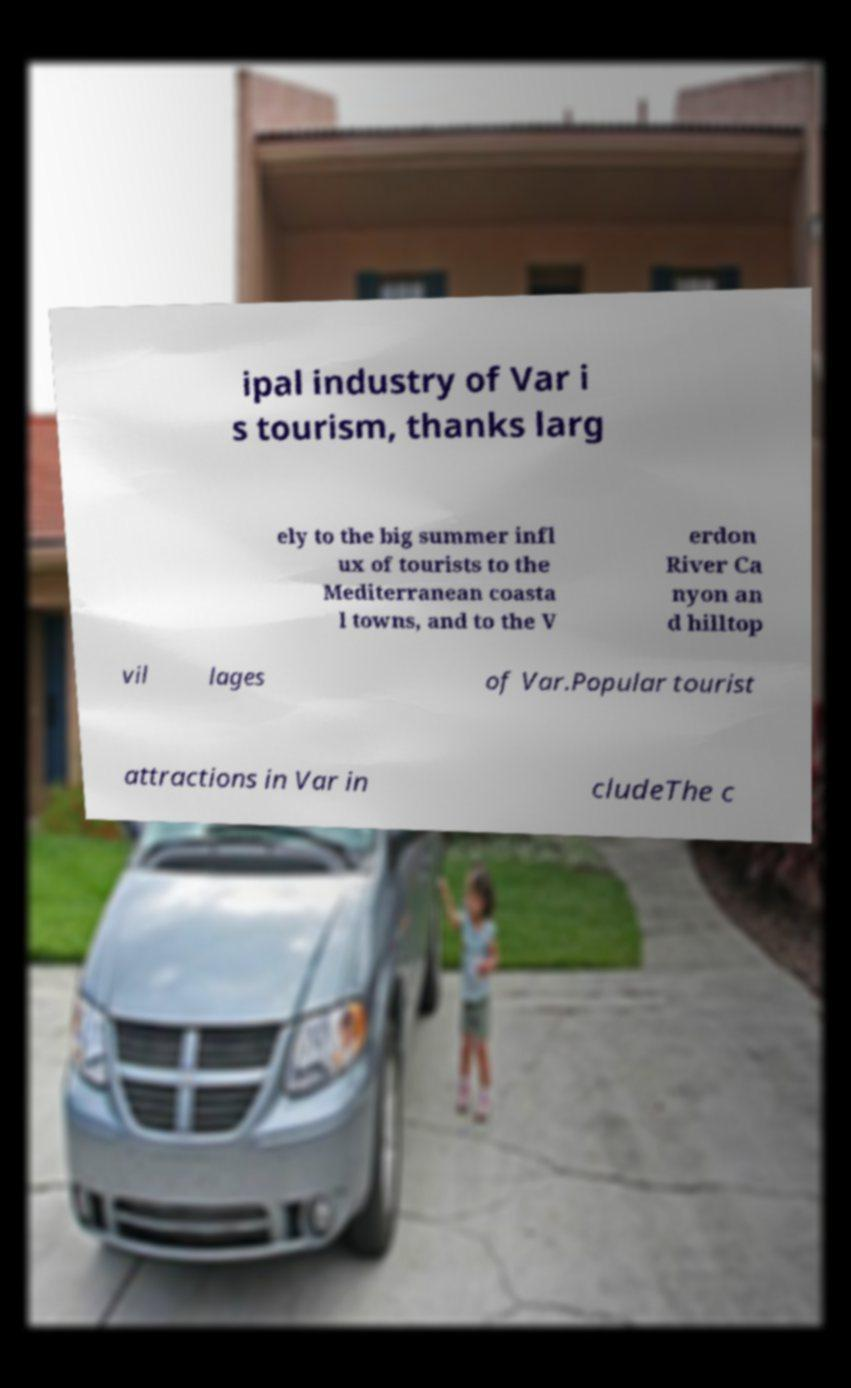What messages or text are displayed in this image? I need them in a readable, typed format. ipal industry of Var i s tourism, thanks larg ely to the big summer infl ux of tourists to the Mediterranean coasta l towns, and to the V erdon River Ca nyon an d hilltop vil lages of Var.Popular tourist attractions in Var in cludeThe c 